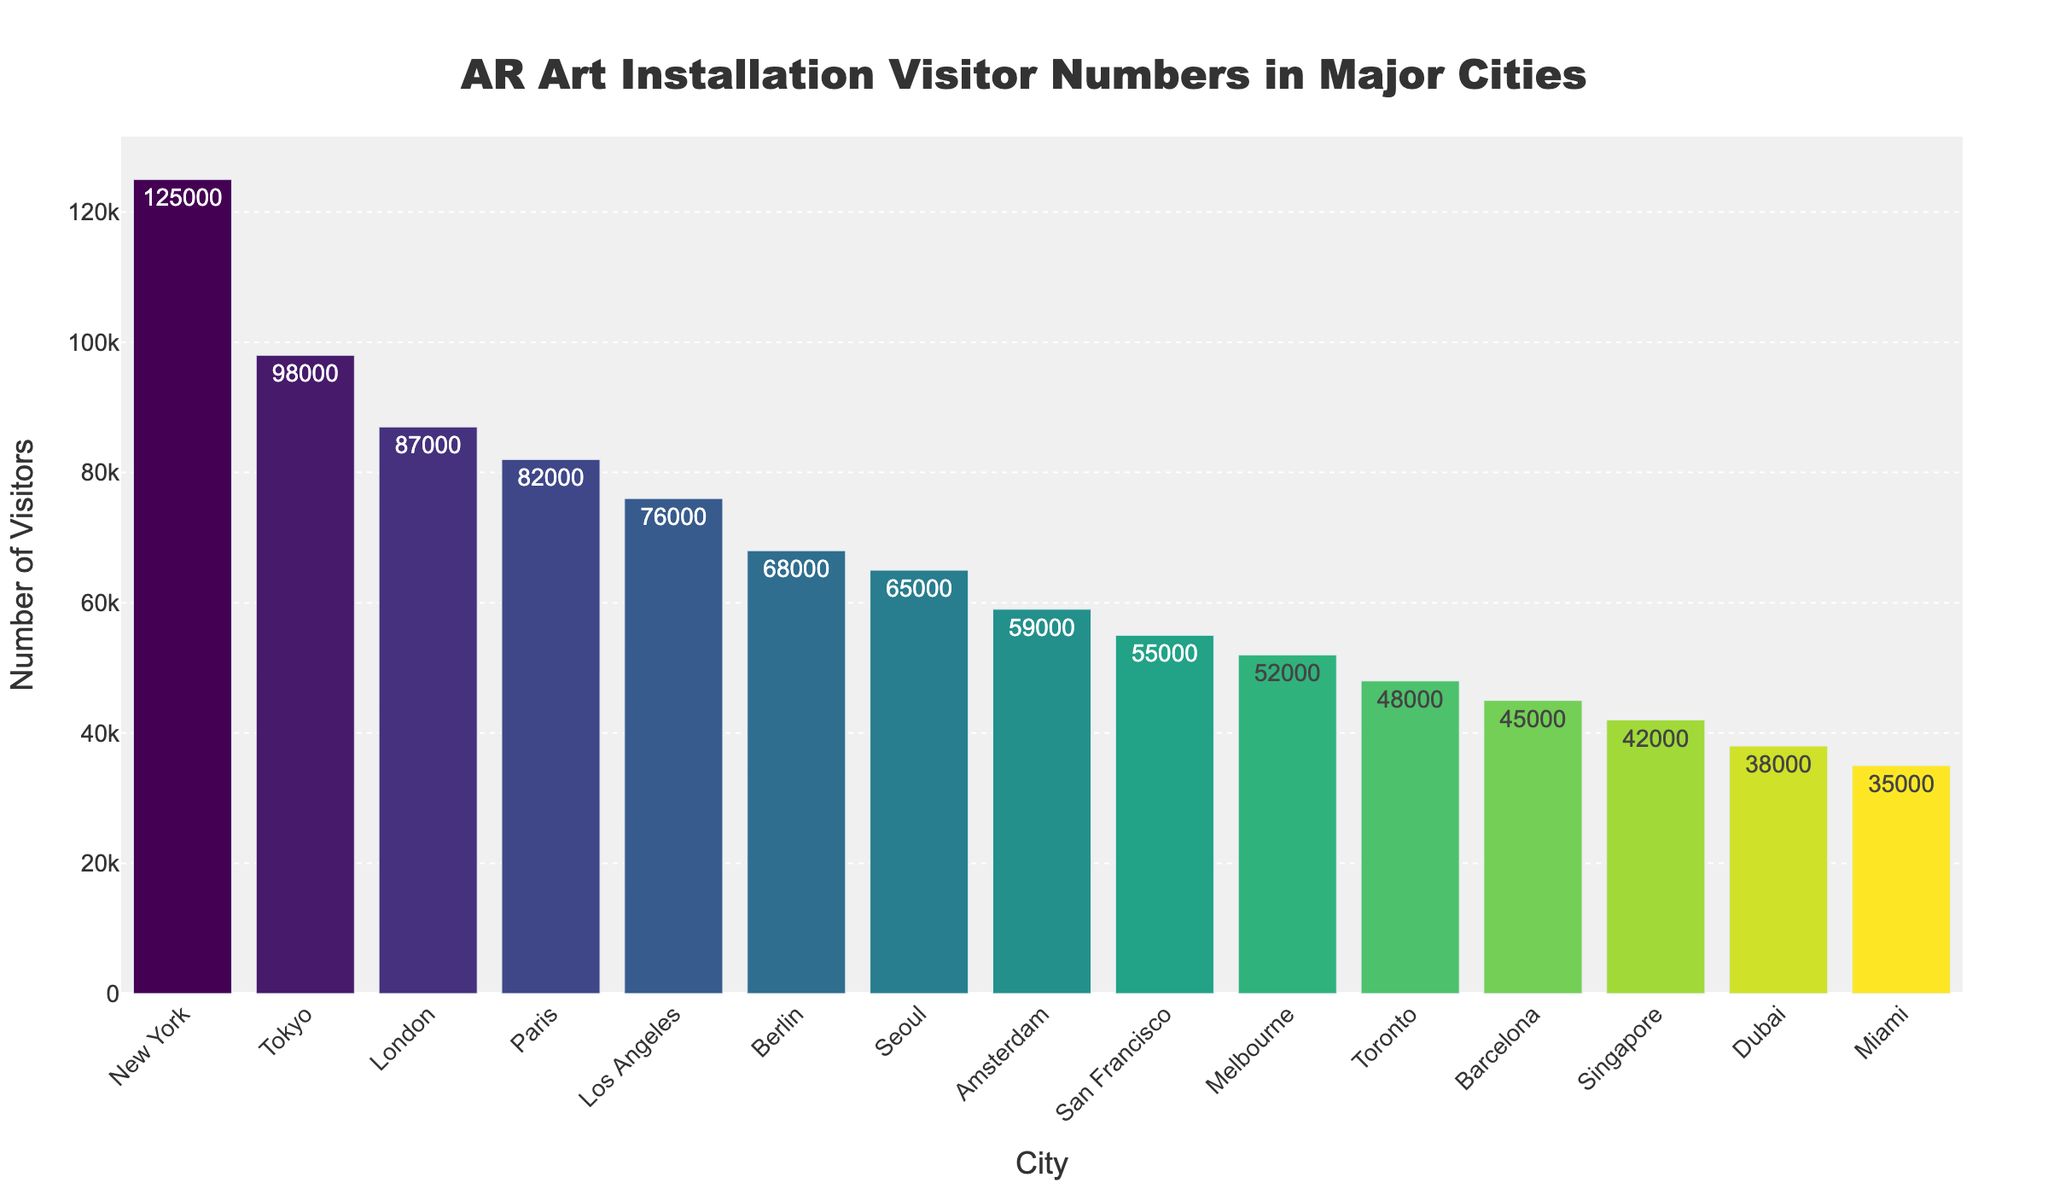What is the city with the highest number of visitors for AR art installations? The city with the highest number of visitors can be seen at the top left of the bar chart, which is the first bar with the highest value.
Answer: New York Which city has fewer visitors, Tokyo or Seoul? Compare the heights of the bars representing Tokyo and Seoul. The bar for Seoul is much shorter.
Answer: Seoul What is the combined number of visitors for New York, Tokyo, and London? Sum the visitor counts for New York, Tokyo, and London, which are 125,000 + 98,000 + 87,000 = 310,000.
Answer: 310,000 How many more visitors did Paris have compared to Los Angeles? The visitor count for Paris is 82,000 and for Los Angeles is 76,000. Subtract 76,000 from 82,000 to get the difference, which is 6,000.
Answer: 6,000 Which city has a higher visitor count, San Francisco or Melbourne? Compare the heights of the bars for San Francisco and Melbourne. The bar for San Francisco is slightly higher.
Answer: San Francisco What’s the visitor count for the city with the least number of visitors shown? Locate the shortest bar on the chart, which represents the city with the least number of visitors, which is Miami with 35,000 visitors.
Answer: 35,000 Is the visitor count for Amsterdam closer to that of Seoul or Toronto? Compare the visitor counts for Amsterdam (59,000), Seoul (65,000), and Toronto (48,000). The difference between Amsterdam and Seoul is 6,000, and the difference between Amsterdam and Toronto is 11,000. Hence, Amsterdam's visitor count is closer to Seoul's.
Answer: Seoul What is the average number of visitors for the cities shown? Sum all visitor counts and divide by the number of cities. The total number of visitors is 1,000,000, and the number of cities is 15. So, the average is 1,000,000 / 15 = 66,666.67
Answer: 66,666.67 If we combine visitor counts of the least visited six cities, what is the total? Add the visitor counts for the least six cities: Melbourne (52,000), Toronto (48,000), Barcelona (45,000), Singapore (42,000), Dubai (38,000), and Miami (35,000). The total is 260,000.
Answer: 260,000 